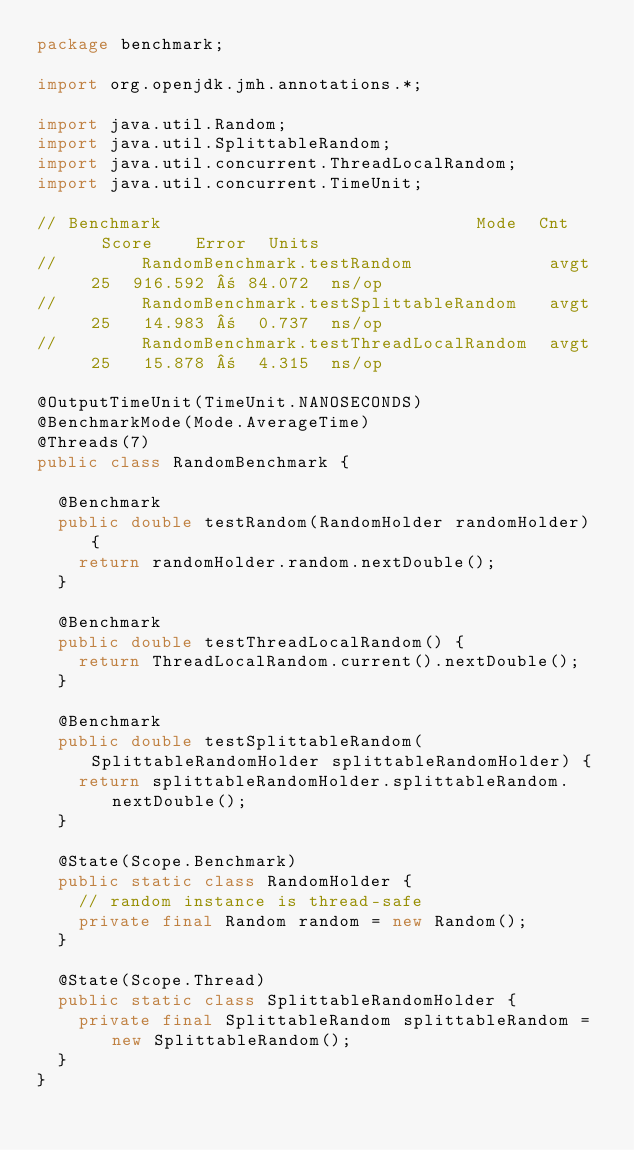<code> <loc_0><loc_0><loc_500><loc_500><_Java_>package benchmark;

import org.openjdk.jmh.annotations.*;

import java.util.Random;
import java.util.SplittableRandom;
import java.util.concurrent.ThreadLocalRandom;
import java.util.concurrent.TimeUnit;

// Benchmark                              Mode  Cnt    Score    Error  Units
//        RandomBenchmark.testRandom             avgt   25  916.592 ± 84.072  ns/op
//        RandomBenchmark.testSplittableRandom   avgt   25   14.983 ±  0.737  ns/op
//        RandomBenchmark.testThreadLocalRandom  avgt   25   15.878 ±  4.315  ns/op

@OutputTimeUnit(TimeUnit.NANOSECONDS)
@BenchmarkMode(Mode.AverageTime)
@Threads(7)
public class RandomBenchmark {

  @Benchmark
  public double testRandom(RandomHolder randomHolder) {
    return randomHolder.random.nextDouble();
  }

  @Benchmark
  public double testThreadLocalRandom() {
    return ThreadLocalRandom.current().nextDouble();
  }

  @Benchmark
  public double testSplittableRandom(SplittableRandomHolder splittableRandomHolder) {
    return splittableRandomHolder.splittableRandom.nextDouble();
  }

  @State(Scope.Benchmark)
  public static class RandomHolder {
    // random instance is thread-safe
    private final Random random = new Random();
  }

  @State(Scope.Thread)
  public static class SplittableRandomHolder {
    private final SplittableRandom splittableRandom = new SplittableRandom();
  }
}
</code> 